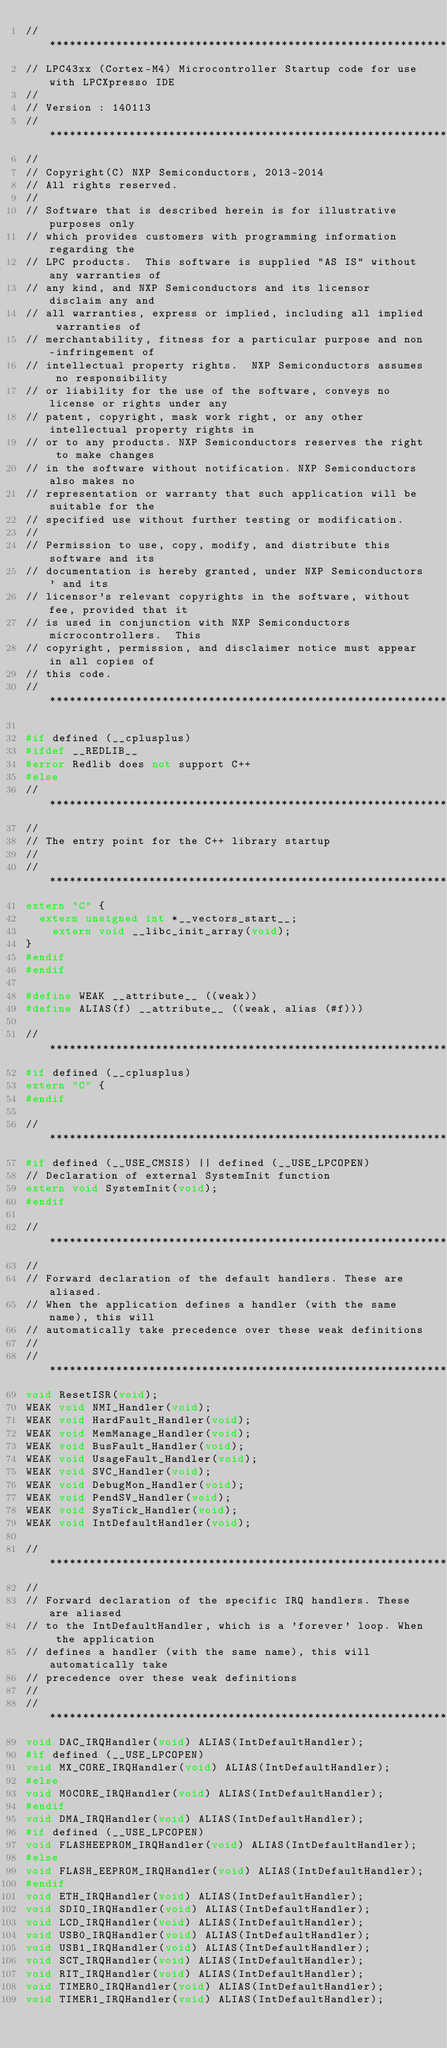Convert code to text. <code><loc_0><loc_0><loc_500><loc_500><_C++_>//*****************************************************************************
// LPC43xx (Cortex-M4) Microcontroller Startup code for use with LPCXpresso IDE
//
// Version : 140113
//*****************************************************************************
//
// Copyright(C) NXP Semiconductors, 2013-2014
// All rights reserved.
//
// Software that is described herein is for illustrative purposes only
// which provides customers with programming information regarding the
// LPC products.  This software is supplied "AS IS" without any warranties of
// any kind, and NXP Semiconductors and its licensor disclaim any and
// all warranties, express or implied, including all implied warranties of
// merchantability, fitness for a particular purpose and non-infringement of
// intellectual property rights.  NXP Semiconductors assumes no responsibility
// or liability for the use of the software, conveys no license or rights under any
// patent, copyright, mask work right, or any other intellectual property rights in
// or to any products. NXP Semiconductors reserves the right to make changes
// in the software without notification. NXP Semiconductors also makes no
// representation or warranty that such application will be suitable for the
// specified use without further testing or modification.
//
// Permission to use, copy, modify, and distribute this software and its
// documentation is hereby granted, under NXP Semiconductors' and its
// licensor's relevant copyrights in the software, without fee, provided that it
// is used in conjunction with NXP Semiconductors microcontrollers.  This
// copyright, permission, and disclaimer notice must appear in all copies of
// this code.
//*****************************************************************************

#if defined (__cplusplus)
#ifdef __REDLIB__
#error Redlib does not support C++
#else
//*****************************************************************************
//
// The entry point for the C++ library startup
//
//*****************************************************************************
extern "C" {
	extern unsigned int *__vectors_start__;
    extern void __libc_init_array(void);
}
#endif
#endif

#define WEAK __attribute__ ((weak))
#define ALIAS(f) __attribute__ ((weak, alias (#f)))

//*****************************************************************************
#if defined (__cplusplus)
extern "C" {
#endif

//*****************************************************************************
#if defined (__USE_CMSIS) || defined (__USE_LPCOPEN)
// Declaration of external SystemInit function
extern void SystemInit(void);
#endif

//*****************************************************************************
//
// Forward declaration of the default handlers. These are aliased.
// When the application defines a handler (with the same name), this will 
// automatically take precedence over these weak definitions
//
//*****************************************************************************
void ResetISR(void);
WEAK void NMI_Handler(void);
WEAK void HardFault_Handler(void);
WEAK void MemManage_Handler(void);
WEAK void BusFault_Handler(void);
WEAK void UsageFault_Handler(void);
WEAK void SVC_Handler(void);
WEAK void DebugMon_Handler(void);
WEAK void PendSV_Handler(void);
WEAK void SysTick_Handler(void);
WEAK void IntDefaultHandler(void);

//*****************************************************************************
//
// Forward declaration of the specific IRQ handlers. These are aliased
// to the IntDefaultHandler, which is a 'forever' loop. When the application
// defines a handler (with the same name), this will automatically take 
// precedence over these weak definitions
//
//*****************************************************************************
void DAC_IRQHandler(void) ALIAS(IntDefaultHandler);
#if defined (__USE_LPCOPEN)
void MX_CORE_IRQHandler(void) ALIAS(IntDefaultHandler);
#else
void M0CORE_IRQHandler(void) ALIAS(IntDefaultHandler);
#endif
void DMA_IRQHandler(void) ALIAS(IntDefaultHandler);
#if defined (__USE_LPCOPEN)
void FLASHEEPROM_IRQHandler(void) ALIAS(IntDefaultHandler);
#else
void FLASH_EEPROM_IRQHandler(void) ALIAS(IntDefaultHandler);
#endif
void ETH_IRQHandler(void) ALIAS(IntDefaultHandler);
void SDIO_IRQHandler(void) ALIAS(IntDefaultHandler);
void LCD_IRQHandler(void) ALIAS(IntDefaultHandler);
void USB0_IRQHandler(void) ALIAS(IntDefaultHandler);
void USB1_IRQHandler(void) ALIAS(IntDefaultHandler);
void SCT_IRQHandler(void) ALIAS(IntDefaultHandler);
void RIT_IRQHandler(void) ALIAS(IntDefaultHandler);
void TIMER0_IRQHandler(void) ALIAS(IntDefaultHandler);
void TIMER1_IRQHandler(void) ALIAS(IntDefaultHandler);</code> 